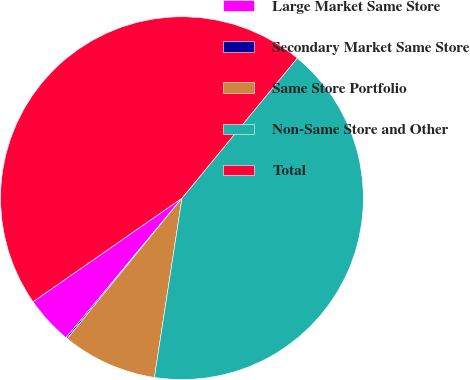Convert chart to OTSL. <chart><loc_0><loc_0><loc_500><loc_500><pie_chart><fcel>Large Market Same Store<fcel>Secondary Market Same Store<fcel>Same Store Portfolio<fcel>Non-Same Store and Other<fcel>Total<nl><fcel>4.3%<fcel>0.13%<fcel>8.47%<fcel>41.46%<fcel>45.63%<nl></chart> 